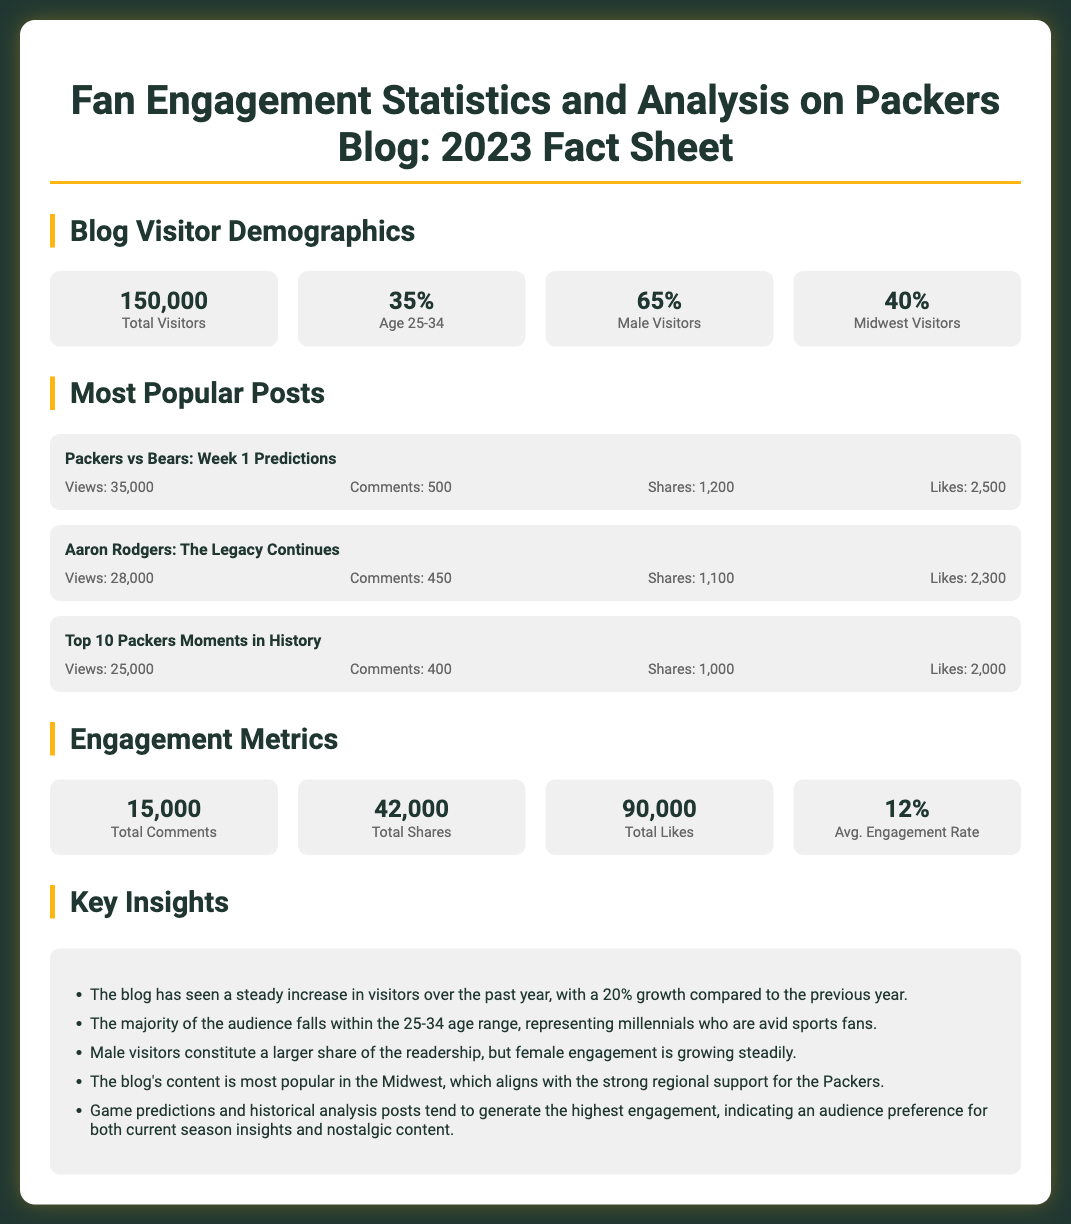What is the total number of blog visitors? The total number of blog visitors is presented in the statistics section of the document as 150,000.
Answer: 150,000 What percentage of visitors are aged 25-34? The percentage of visitors in the age range of 25-34 is specified in the demographics section as 35%.
Answer: 35% Which post has the highest number of views? The post with the highest number of views is indicated under the popular posts section as "Packers vs Bears: Week 1 Predictions" with 35,000 views.
Answer: Packers vs Bears: Week 1 Predictions What is the total number of likes across all posts? The total number of likes is given in the engagement metrics as 90,000.
Answer: 90,000 What is the average engagement rate mentioned in the document? The average engagement rate is detailed in the engagement metrics as 12%.
Answer: 12% Which region has the largest share of blog visitors? The region with the largest share of blog visitors is identified in demographic statistics as the Midwest with 40%.
Answer: Midwest What type of content generates the highest engagement according to the key insights? The key insights indicate that game predictions and historical analysis posts generate the highest engagement.
Answer: Game predictions and historical analysis posts How many total comments were made on the blog? The total number of comments on the blog is stated in engagement metrics as 15,000.
Answer: 15,000 